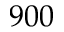<formula> <loc_0><loc_0><loc_500><loc_500>9 0 0</formula> 